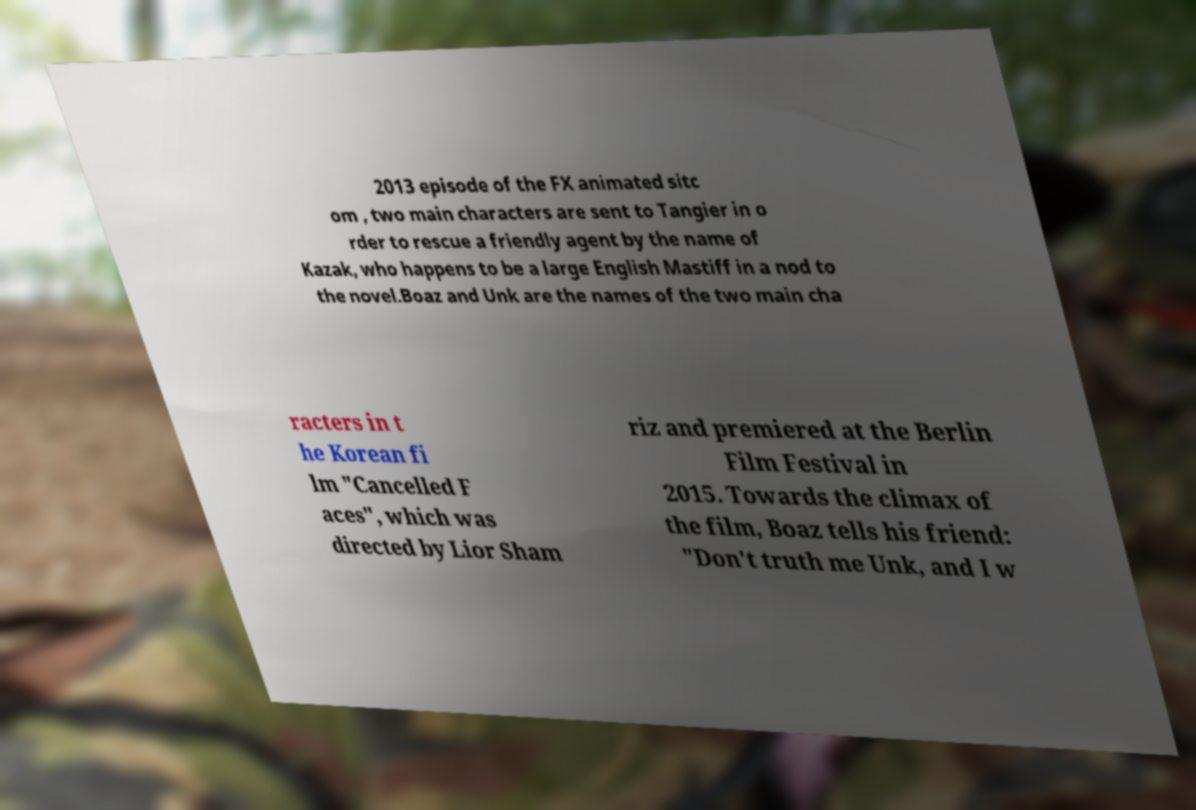Can you accurately transcribe the text from the provided image for me? 2013 episode of the FX animated sitc om , two main characters are sent to Tangier in o rder to rescue a friendly agent by the name of Kazak, who happens to be a large English Mastiff in a nod to the novel.Boaz and Unk are the names of the two main cha racters in t he Korean fi lm "Cancelled F aces", which was directed by Lior Sham riz and premiered at the Berlin Film Festival in 2015. Towards the climax of the film, Boaz tells his friend: "Don't truth me Unk, and I w 